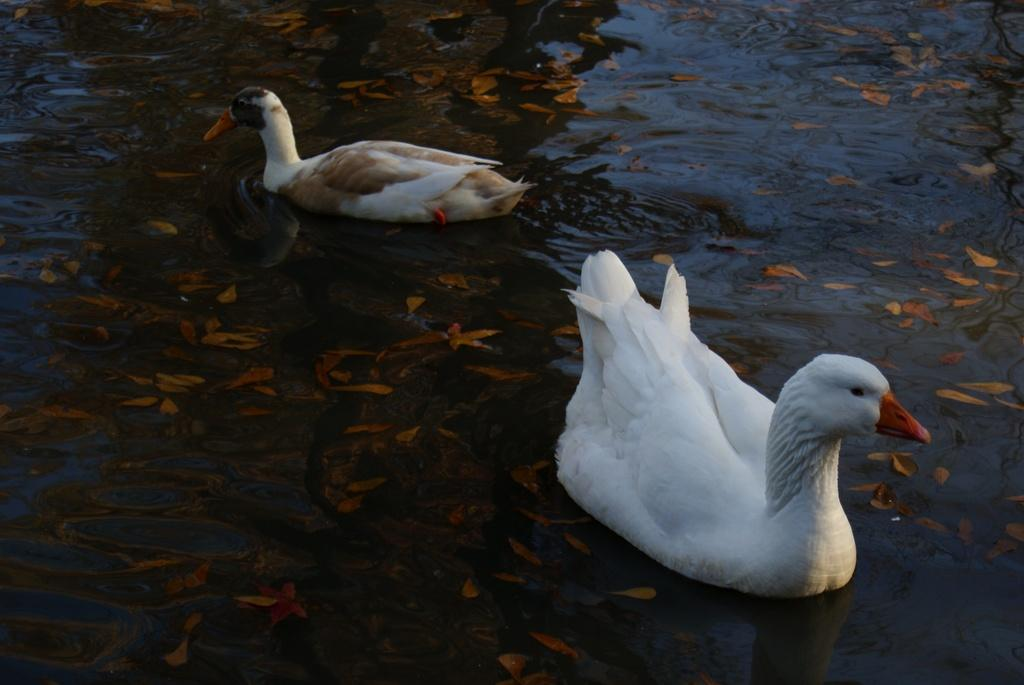What is visible in the image? Water, birds, and leaves are visible in the image. What type of animals can be seen in the image? Birds can be seen in the image. What type of vegetation is present in the image? Leaves are present in the image. Can you see any wounds on the birds in the image? There is no indication of any wounds on the birds in the image. What type of skirt is being worn by the water in the image? The water in the image is not wearing a skirt; it is a natural body of water. 